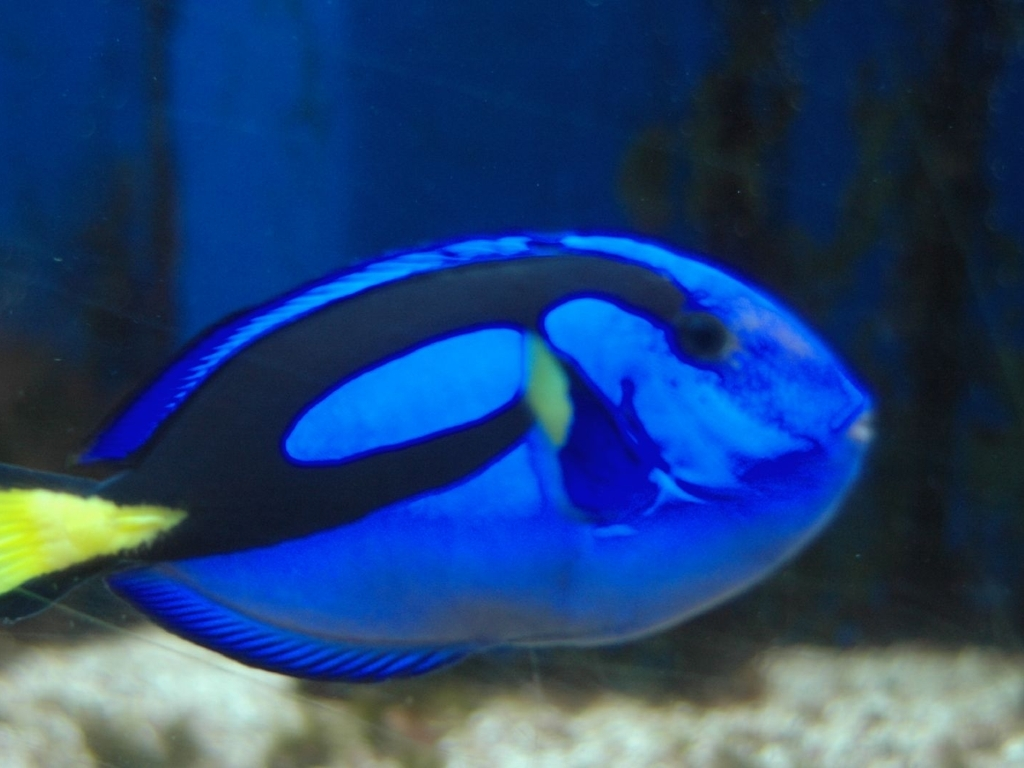How is the background in the image? The background in the image is heavily blurred, which accentuates the subject by reducing visual noise and creating a pleasing bokeh effect that directs the viewer's attention to the vibrant colors and details of the fish in the foreground. 